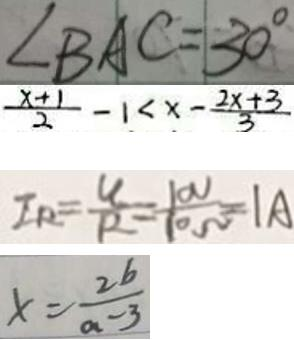Convert formula to latex. <formula><loc_0><loc_0><loc_500><loc_500>\angle B A C = 3 0 ^ { \circ } 
 \frac { x + 1 } { 2 } - 1 < x - \frac { 2 x + 3 } { 3 } 
 I _ { R } = \frac { U } { R } = \frac { 1 0 V } { 1 0 \Omega } = 1 A 
 x = \frac { 2 b } { a - 3 }</formula> 